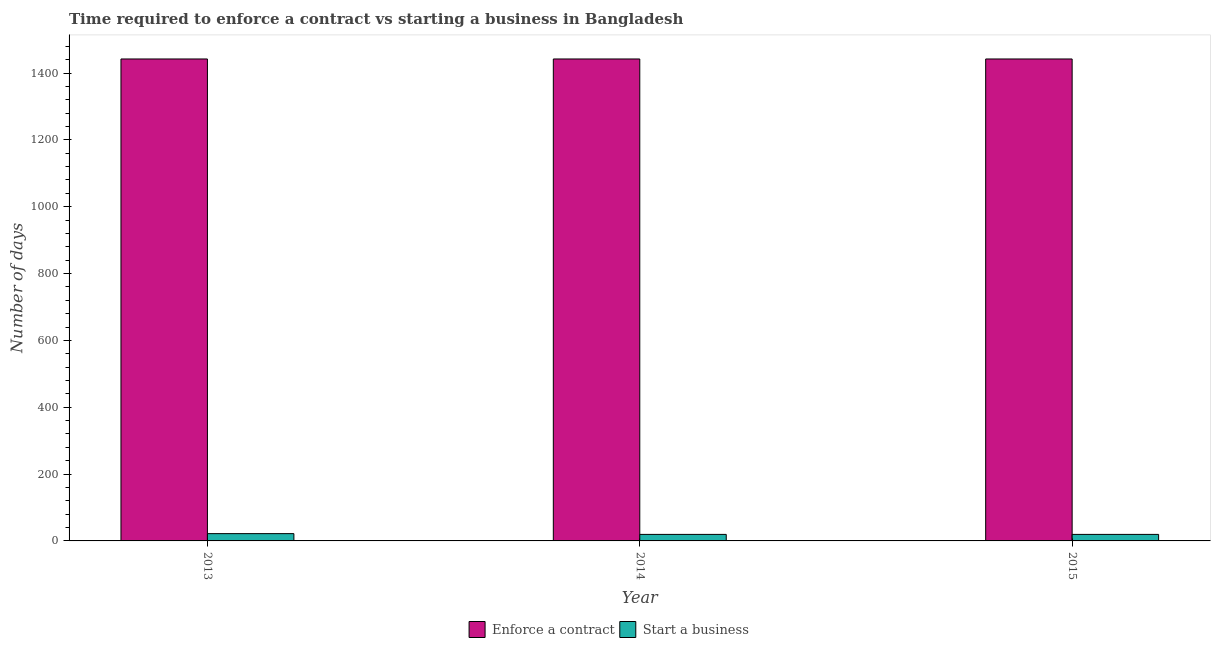How many different coloured bars are there?
Your answer should be compact. 2. Are the number of bars per tick equal to the number of legend labels?
Your answer should be very brief. Yes. How many bars are there on the 3rd tick from the right?
Your answer should be compact. 2. What is the label of the 3rd group of bars from the left?
Your answer should be compact. 2015. In how many cases, is the number of bars for a given year not equal to the number of legend labels?
Your response must be concise. 0. What is the number of days to enforece a contract in 2015?
Your answer should be very brief. 1442. Across all years, what is the maximum number of days to start a business?
Your answer should be very brief. 21.8. Across all years, what is the minimum number of days to enforece a contract?
Your answer should be compact. 1442. What is the total number of days to enforece a contract in the graph?
Make the answer very short. 4326. What is the difference between the number of days to enforece a contract in 2013 and that in 2014?
Ensure brevity in your answer.  0. What is the difference between the number of days to start a business in 2013 and the number of days to enforece a contract in 2014?
Your answer should be compact. 2.3. What is the average number of days to start a business per year?
Offer a very short reply. 20.27. In the year 2014, what is the difference between the number of days to start a business and number of days to enforece a contract?
Offer a terse response. 0. In how many years, is the number of days to start a business greater than 1200 days?
Offer a very short reply. 0. Is the number of days to start a business in 2013 less than that in 2015?
Provide a short and direct response. No. Is the difference between the number of days to start a business in 2013 and 2014 greater than the difference between the number of days to enforece a contract in 2013 and 2014?
Provide a succinct answer. No. What is the difference between the highest and the second highest number of days to start a business?
Give a very brief answer. 2.3. What is the difference between the highest and the lowest number of days to start a business?
Keep it short and to the point. 2.3. What does the 2nd bar from the left in 2014 represents?
Provide a short and direct response. Start a business. What does the 2nd bar from the right in 2015 represents?
Your response must be concise. Enforce a contract. Does the graph contain grids?
Offer a very short reply. No. Where does the legend appear in the graph?
Your answer should be very brief. Bottom center. How many legend labels are there?
Give a very brief answer. 2. How are the legend labels stacked?
Ensure brevity in your answer.  Horizontal. What is the title of the graph?
Keep it short and to the point. Time required to enforce a contract vs starting a business in Bangladesh. Does "Females" appear as one of the legend labels in the graph?
Your response must be concise. No. What is the label or title of the X-axis?
Offer a terse response. Year. What is the label or title of the Y-axis?
Ensure brevity in your answer.  Number of days. What is the Number of days of Enforce a contract in 2013?
Your response must be concise. 1442. What is the Number of days of Start a business in 2013?
Keep it short and to the point. 21.8. What is the Number of days of Enforce a contract in 2014?
Keep it short and to the point. 1442. What is the Number of days of Enforce a contract in 2015?
Offer a terse response. 1442. Across all years, what is the maximum Number of days of Enforce a contract?
Give a very brief answer. 1442. Across all years, what is the maximum Number of days in Start a business?
Keep it short and to the point. 21.8. Across all years, what is the minimum Number of days in Enforce a contract?
Give a very brief answer. 1442. What is the total Number of days of Enforce a contract in the graph?
Offer a very short reply. 4326. What is the total Number of days in Start a business in the graph?
Ensure brevity in your answer.  60.8. What is the difference between the Number of days in Start a business in 2013 and that in 2015?
Your answer should be compact. 2.3. What is the difference between the Number of days of Enforce a contract in 2014 and that in 2015?
Give a very brief answer. 0. What is the difference between the Number of days of Start a business in 2014 and that in 2015?
Offer a terse response. 0. What is the difference between the Number of days in Enforce a contract in 2013 and the Number of days in Start a business in 2014?
Provide a short and direct response. 1422.5. What is the difference between the Number of days in Enforce a contract in 2013 and the Number of days in Start a business in 2015?
Make the answer very short. 1422.5. What is the difference between the Number of days in Enforce a contract in 2014 and the Number of days in Start a business in 2015?
Provide a short and direct response. 1422.5. What is the average Number of days in Enforce a contract per year?
Your answer should be compact. 1442. What is the average Number of days in Start a business per year?
Provide a succinct answer. 20.27. In the year 2013, what is the difference between the Number of days of Enforce a contract and Number of days of Start a business?
Your answer should be very brief. 1420.2. In the year 2014, what is the difference between the Number of days of Enforce a contract and Number of days of Start a business?
Your answer should be very brief. 1422.5. In the year 2015, what is the difference between the Number of days in Enforce a contract and Number of days in Start a business?
Ensure brevity in your answer.  1422.5. What is the ratio of the Number of days of Enforce a contract in 2013 to that in 2014?
Your answer should be compact. 1. What is the ratio of the Number of days of Start a business in 2013 to that in 2014?
Offer a very short reply. 1.12. What is the ratio of the Number of days of Start a business in 2013 to that in 2015?
Provide a short and direct response. 1.12. What is the ratio of the Number of days in Enforce a contract in 2014 to that in 2015?
Provide a short and direct response. 1. What is the difference between the highest and the second highest Number of days of Enforce a contract?
Offer a terse response. 0. 